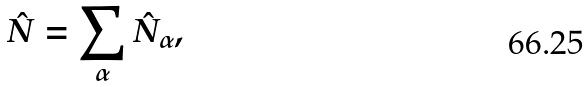<formula> <loc_0><loc_0><loc_500><loc_500>\hat { N } = \sum _ { \alpha } \hat { N } _ { \alpha } ,</formula> 